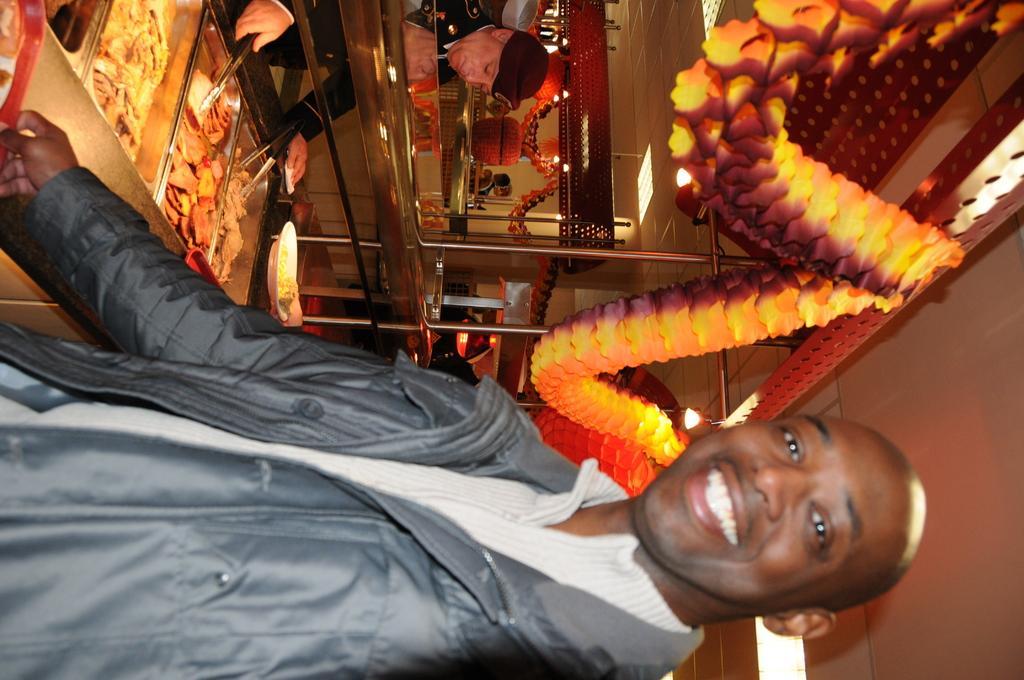Describe this image in one or two sentences. In this image in front there is a person wearing a smile on his face. Beside his there are food items on the table. There are spoons. There is a person standing in front of the table and he is holding the spoon. In the center of the image there are decorative flowers. In the background of the image there is a mirror. On top of the image there are lights. 